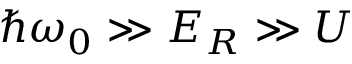<formula> <loc_0><loc_0><loc_500><loc_500>\hbar { \omega } _ { 0 } \gg E _ { R } \gg U</formula> 